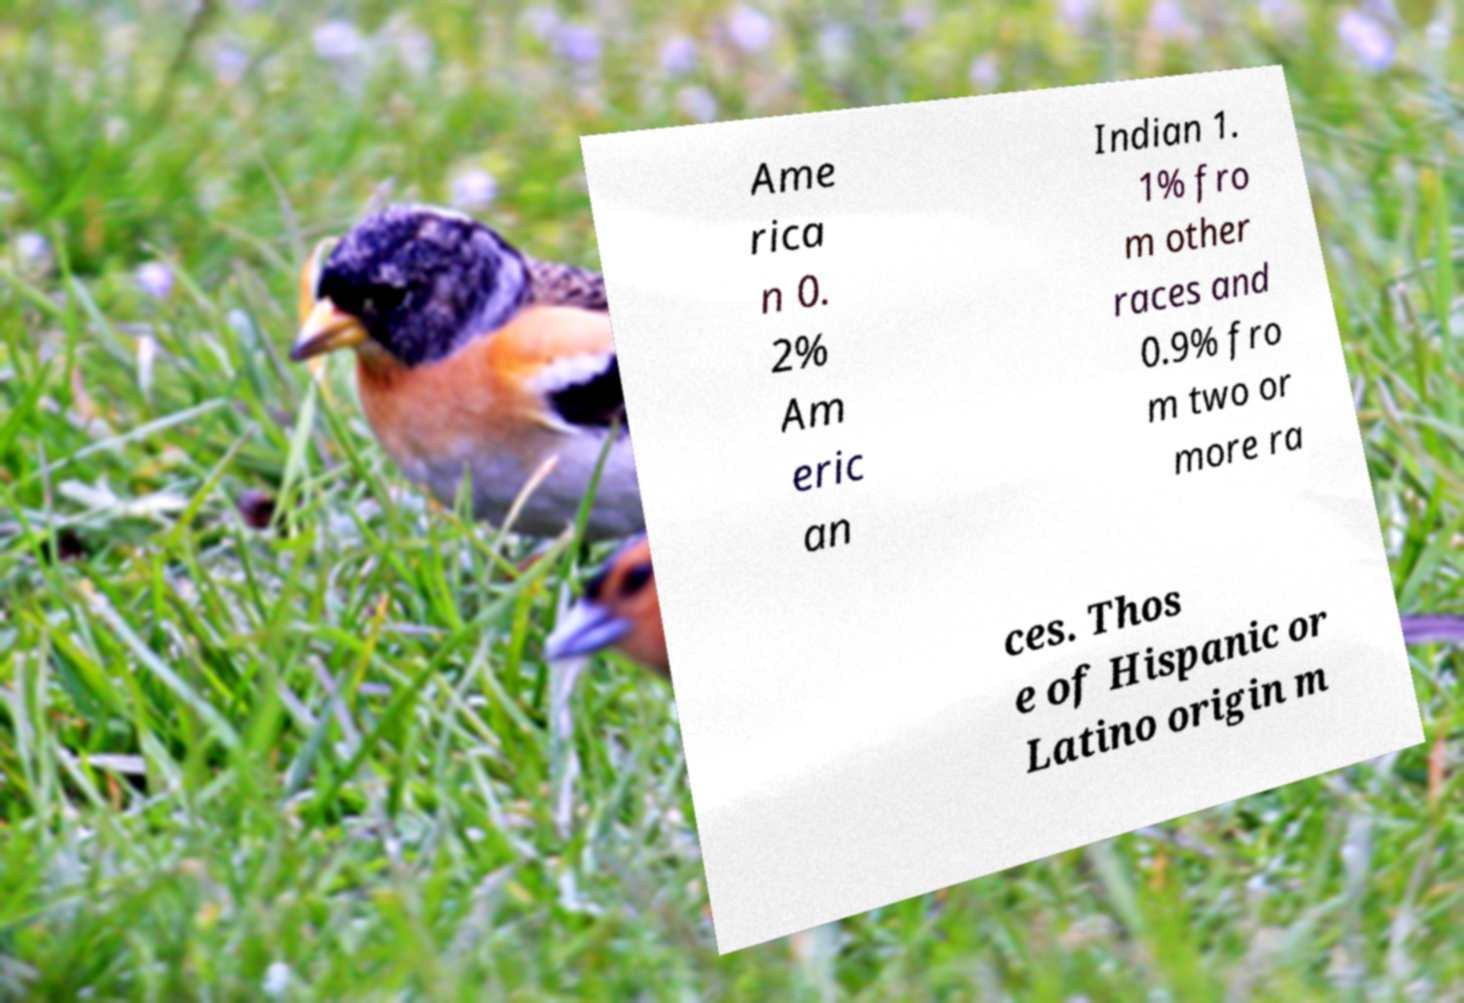What messages or text are displayed in this image? I need them in a readable, typed format. Ame rica n 0. 2% Am eric an Indian 1. 1% fro m other races and 0.9% fro m two or more ra ces. Thos e of Hispanic or Latino origin m 